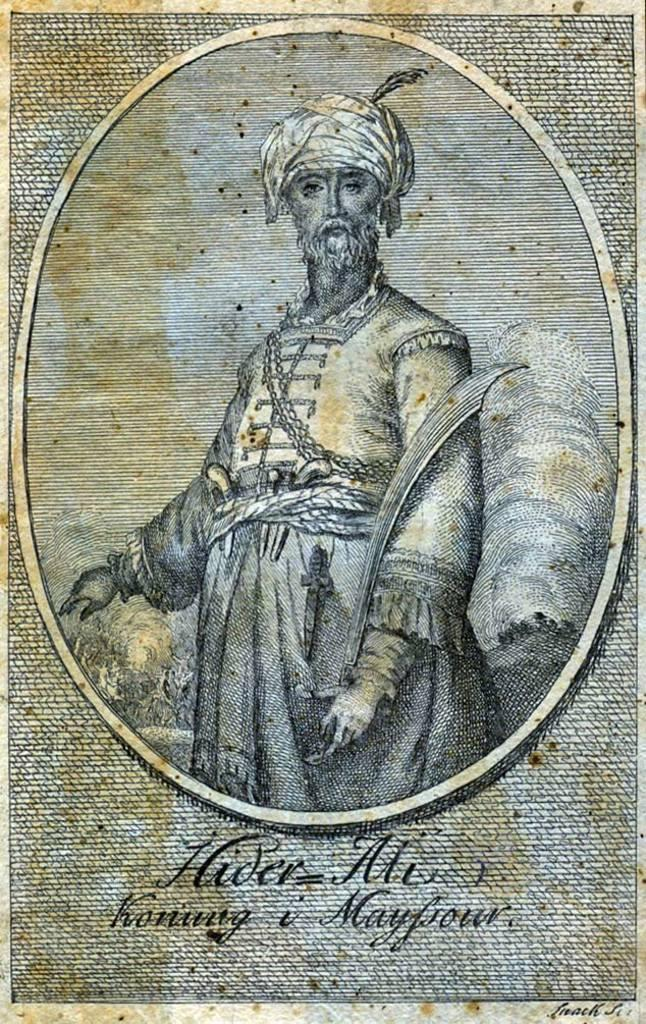What is the main object in the image? There is a paper in the image. What is depicted on the paper? There is a picture of a man on the paper. What is the man in the picture doing? The man in the picture is standing. What else can be seen on the paper besides the picture? There is text at the bottom of the paper. What type of pet is sitting next to the man in the image? There is no pet present in the image; it only features a paper with a picture of a man standing. 